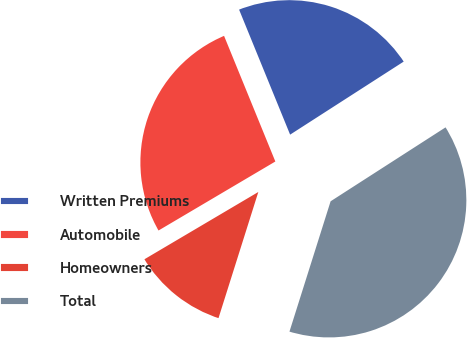Convert chart. <chart><loc_0><loc_0><loc_500><loc_500><pie_chart><fcel>Written Premiums<fcel>Automobile<fcel>Homeowners<fcel>Total<nl><fcel>22.07%<fcel>27.32%<fcel>11.64%<fcel>38.96%<nl></chart> 